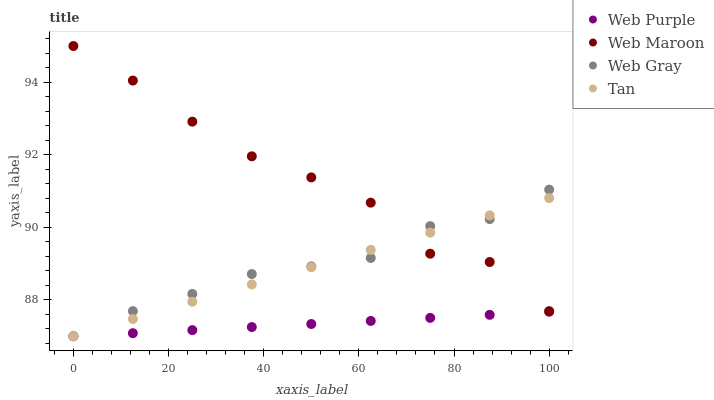Does Web Purple have the minimum area under the curve?
Answer yes or no. Yes. Does Web Maroon have the maximum area under the curve?
Answer yes or no. Yes. Does Web Gray have the minimum area under the curve?
Answer yes or no. No. Does Web Gray have the maximum area under the curve?
Answer yes or no. No. Is Tan the smoothest?
Answer yes or no. Yes. Is Web Maroon the roughest?
Answer yes or no. Yes. Is Web Gray the smoothest?
Answer yes or no. No. Is Web Gray the roughest?
Answer yes or no. No. Does Web Purple have the lowest value?
Answer yes or no. Yes. Does Web Maroon have the lowest value?
Answer yes or no. No. Does Web Maroon have the highest value?
Answer yes or no. Yes. Does Web Gray have the highest value?
Answer yes or no. No. Is Web Purple less than Web Maroon?
Answer yes or no. Yes. Is Web Maroon greater than Web Purple?
Answer yes or no. Yes. Does Web Purple intersect Web Gray?
Answer yes or no. Yes. Is Web Purple less than Web Gray?
Answer yes or no. No. Is Web Purple greater than Web Gray?
Answer yes or no. No. Does Web Purple intersect Web Maroon?
Answer yes or no. No. 